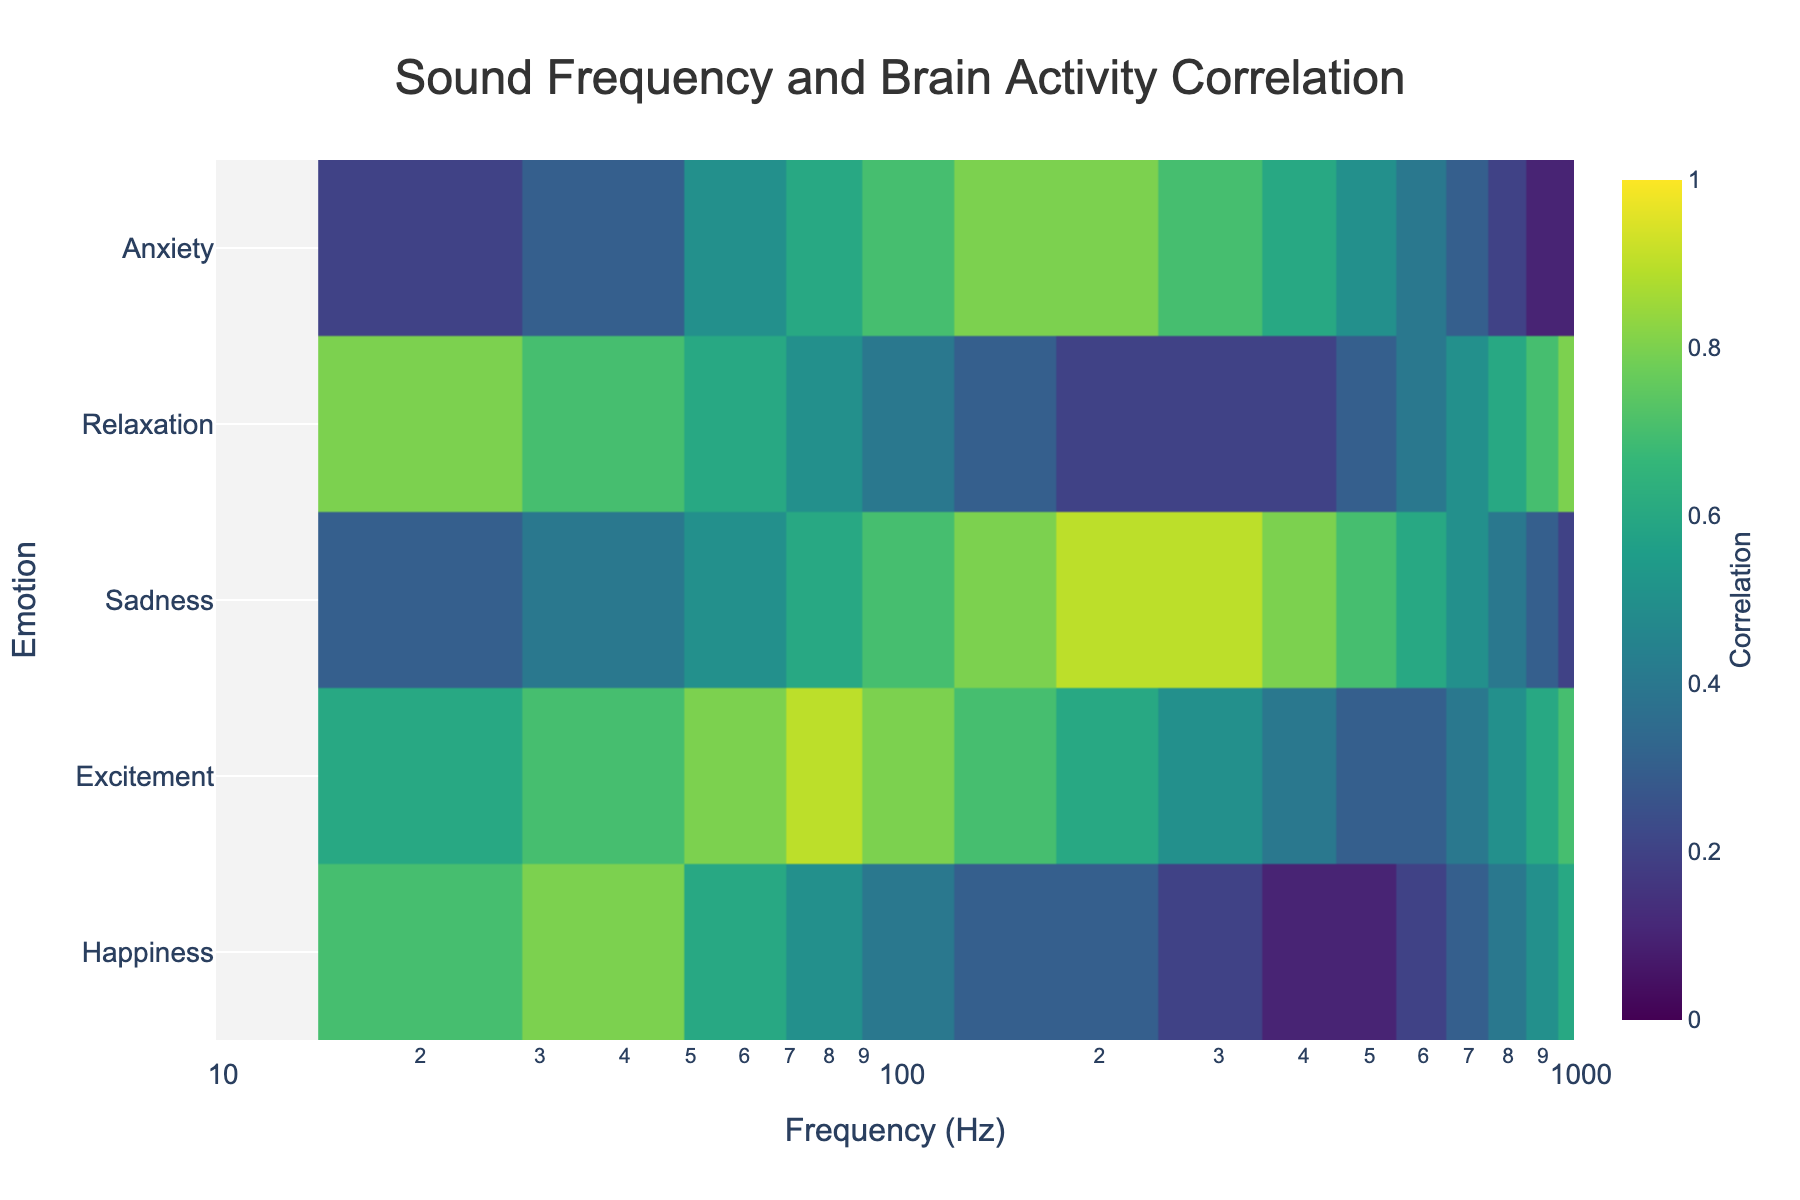What is the title of the heatmap? The title is located at the top center of the heatmap. It is usually in a larger font size compared to other texts. The title of the heatmap here is "Sound Frequency and Brain Activity Correlation".
Answer: Sound Frequency and Brain Activity Correlation What does the color scale represent? The color scale, usually positioned on the right side of the heatmap, indicates the correlation values. Darker colors (closer to dark blue) represent low correlation values, while lighter colors (closer to yellow) indicate high correlation values. The min value is 0 and the max value is 1.
Answer: Correlation values from 0 to 1 For the frequency of 20 Hz, which emotion has the highest correlation? Locate the row for 20 Hz on the x-axis. Among the values corresponding to 20 Hz, the highest value is 0.8 which corresponds to Relaxation.
Answer: Relaxation Which frequency shows the highest correlation with Anxiety? Locate the values under the Anxiety row and identify the highest correlation value. The highest value for Anxiety is 0.8 corresponding to frequencies 150 Hz, 200 Hz, and 300 Hz.
Answer: 150 Hz, 200 Hz, and 300 Hz At what frequencies does Excitement have a correlation of 0.7? Locate the Excitement row and identify all the values that are 0.7. The values of 0.7 are present at frequencies 40 Hz and 1000 Hz.
Answer: 40 Hz and 1000 Hz What is the difference in correlation for Sadness between frequencies 60 Hz and 300 Hz? Find the correlation values for Sadness at 60 Hz and 300 Hz. The values are 0.5 and 0.9 respectively. Subtract the former from the latter: 0.9 - 0.5 = 0.4.
Answer: 0.4 Which emotion shows a consistent decrease in correlation as frequency increases? Observe the correlation values for each emotion across increasing frequencies. Happiness consistently decreases from 0.7 to 0.1 as the frequency increases from 20 Hz to 500 Hz.
Answer: Happiness What is the range of frequencies that show a correlation of 0.6 for Relaxation? Locate the Relaxation row and identify all instances where the value is 0.6. The values are at 20 Hz and 800 Hz. Hence, the range is 20 Hz to 800 Hz.
Answer: 20 Hz to 800 Hz How does the correlation for Anxiety change from 20 Hz to 1000 Hz? Follow the Anxiety row across all frequencies and observe the trend. The correlation values overall increase from 0.2 at 20 Hz to 0.1 at 1000 Hz, showing an overall increasing trend.
Answer: Increases Which three emotions have the highest correlation at 80 Hz? Find the row corresponding to 80 Hz and rank the correlation values. The values are 0.5 (Happiness), 0.9 (Excitement), 0.6 (Sadness), 0.5 (Relaxation), 0.6 (Anxiety). The three highest are 0.9 (Excitement), 0.6 (Sadness, Anxiety).
Answer: Excitement, Sadness, Anxiety 